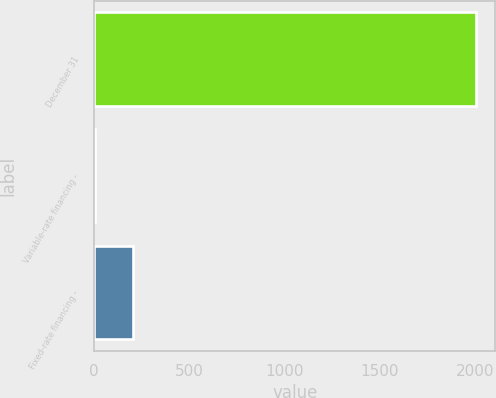<chart> <loc_0><loc_0><loc_500><loc_500><bar_chart><fcel>December 31<fcel>Variable-rate financing -<fcel>Fixed-rate financing -<nl><fcel>2007<fcel>2<fcel>202.5<nl></chart> 